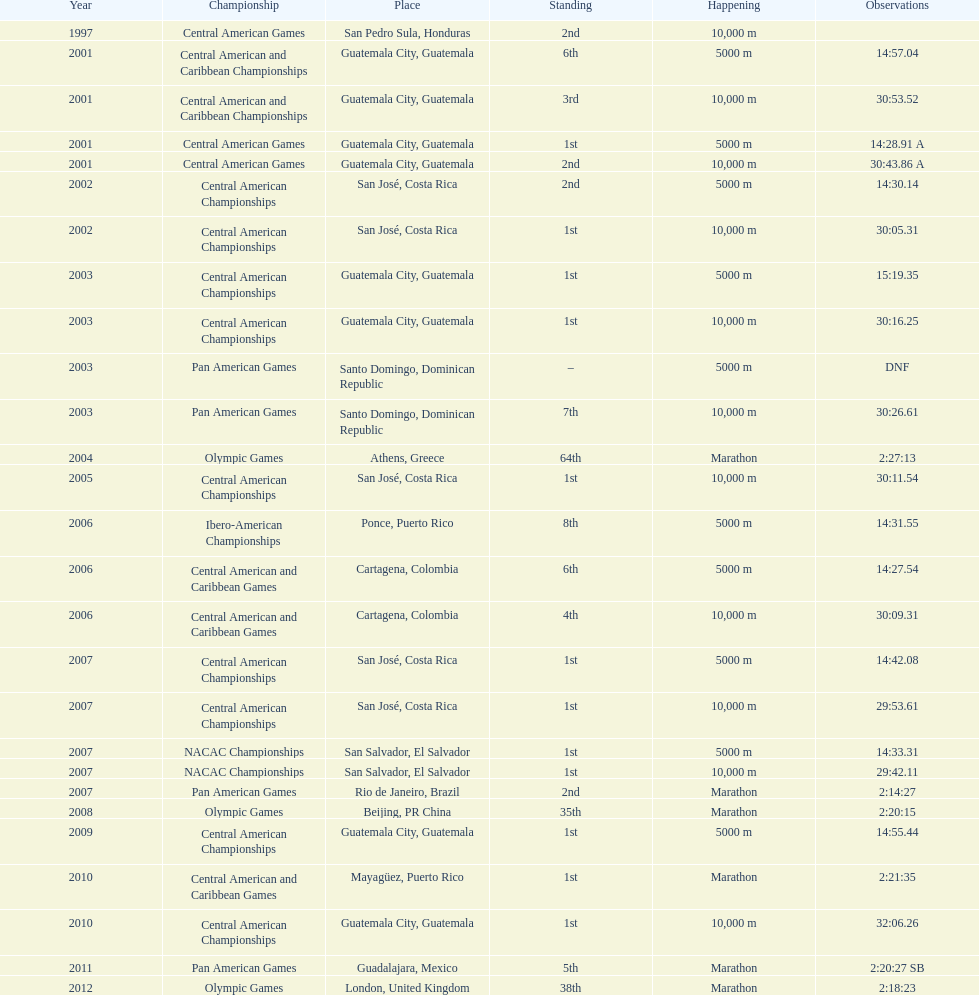Where was the only 64th position held? Athens, Greece. 